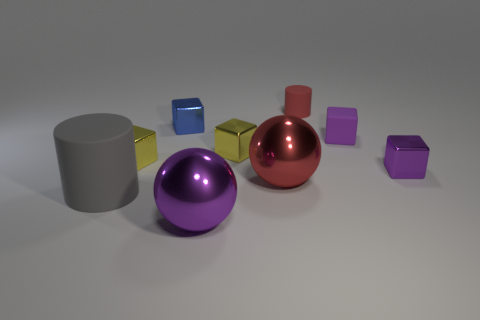Subtract all blue blocks. How many blocks are left? 4 Subtract all small blue metallic blocks. How many blocks are left? 4 Subtract all cyan cubes. Subtract all green spheres. How many cubes are left? 5 Subtract all blocks. How many objects are left? 4 Subtract all red cylinders. Subtract all large gray matte cylinders. How many objects are left? 7 Add 5 red matte cylinders. How many red matte cylinders are left? 6 Add 8 big matte cylinders. How many big matte cylinders exist? 9 Subtract 0 brown blocks. How many objects are left? 9 